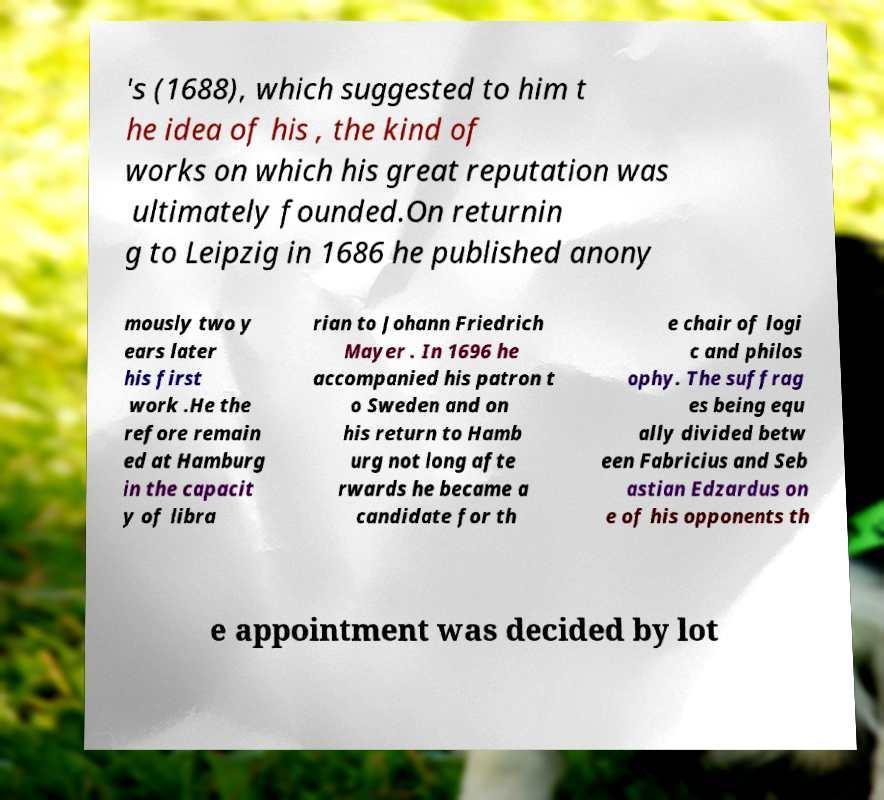Could you extract and type out the text from this image? 's (1688), which suggested to him t he idea of his , the kind of works on which his great reputation was ultimately founded.On returnin g to Leipzig in 1686 he published anony mously two y ears later his first work .He the refore remain ed at Hamburg in the capacit y of libra rian to Johann Friedrich Mayer . In 1696 he accompanied his patron t o Sweden and on his return to Hamb urg not long afte rwards he became a candidate for th e chair of logi c and philos ophy. The suffrag es being equ ally divided betw een Fabricius and Seb astian Edzardus on e of his opponents th e appointment was decided by lot 